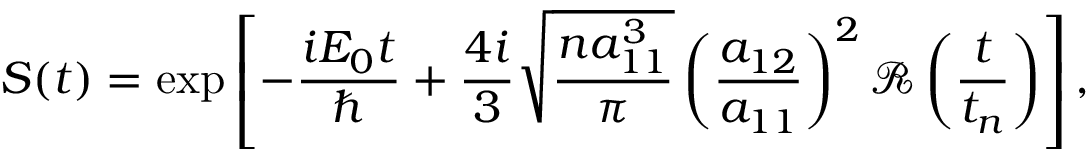<formula> <loc_0><loc_0><loc_500><loc_500>S ( t ) = \exp \left [ - \frac { i E _ { 0 } t } { } + \frac { 4 i } { 3 } \sqrt { \frac { n a _ { 1 1 } ^ { 3 } } { \pi } } \left ( \frac { a _ { 1 2 } } { a _ { 1 1 } } \right ) ^ { 2 } \mathcal { R } \left ( \frac { t } { t _ { n } } \right ) \right ] ,</formula> 